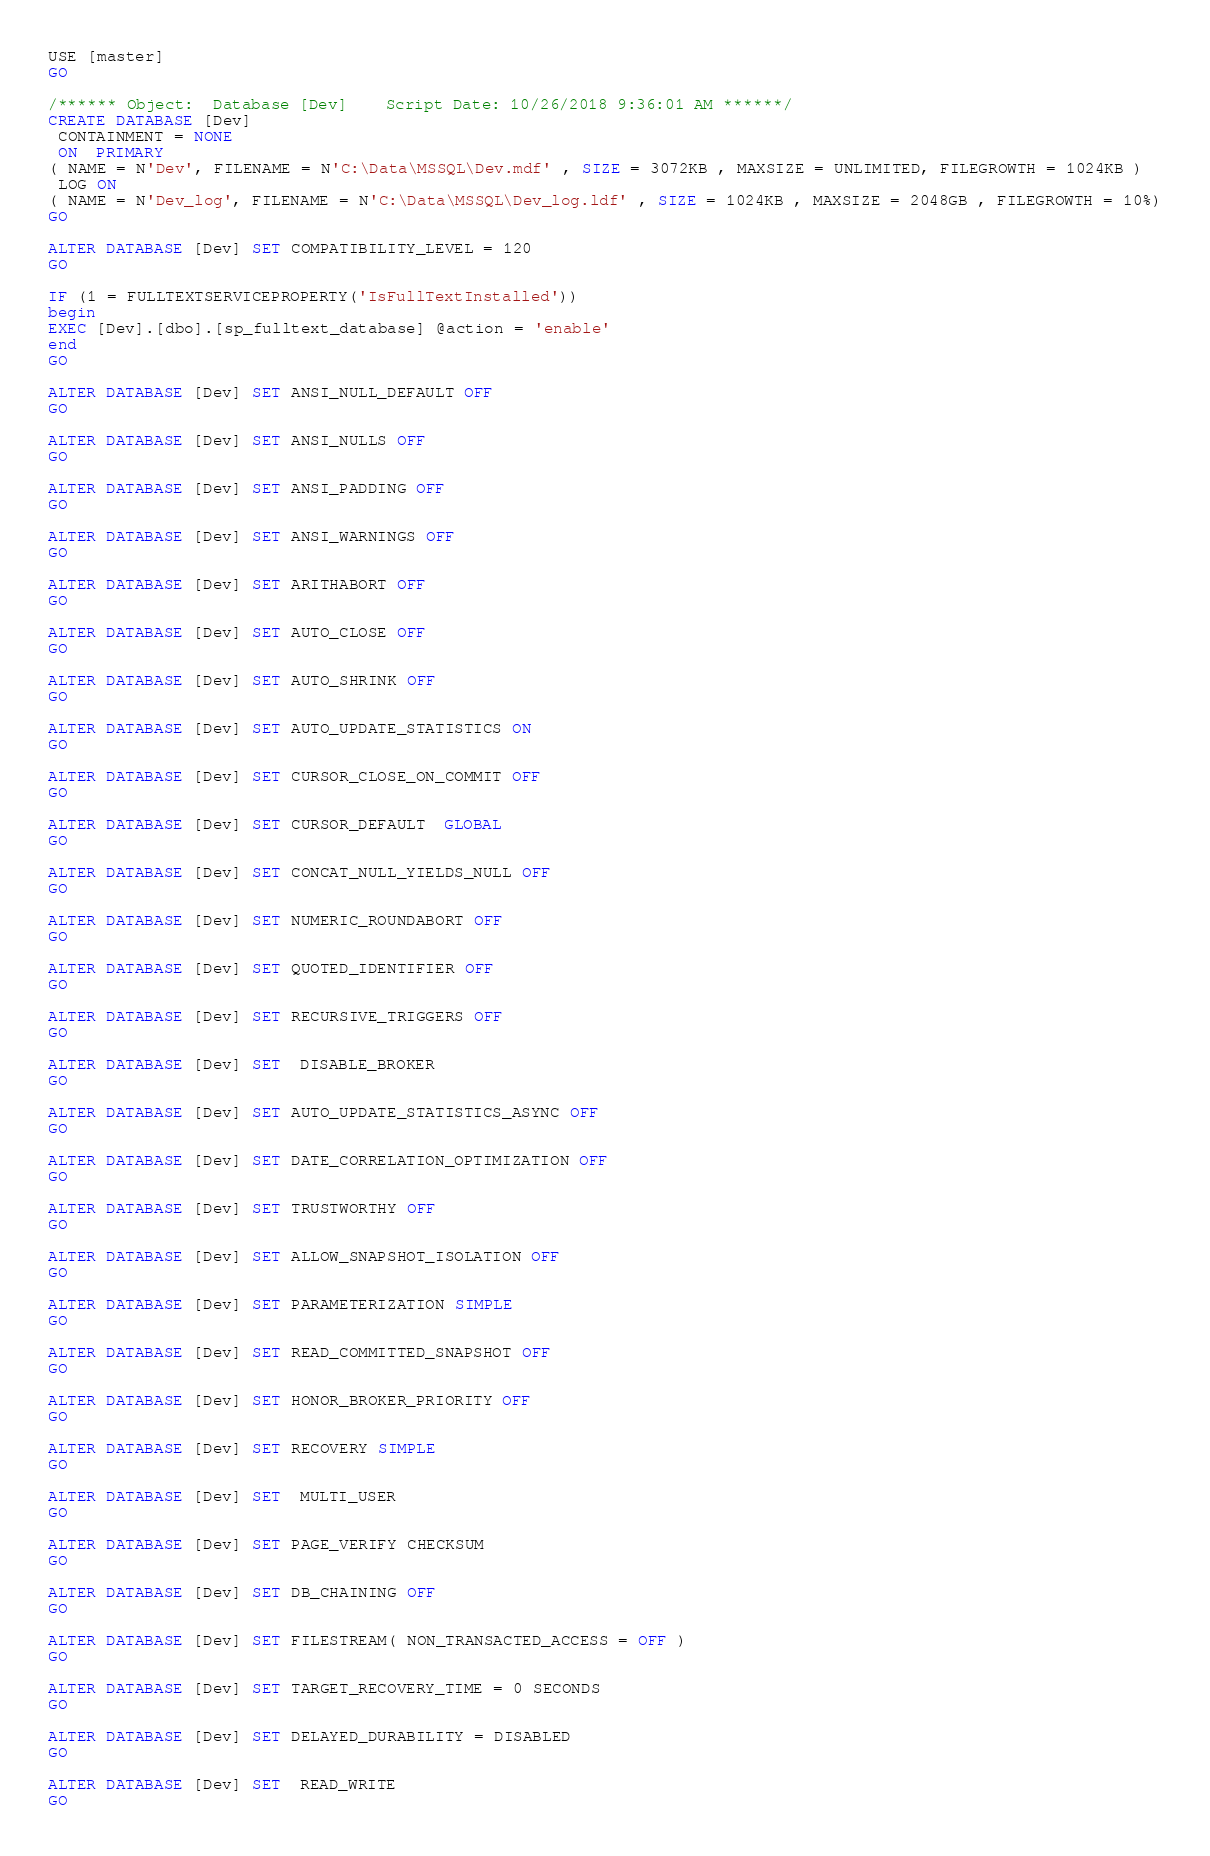Convert code to text. <code><loc_0><loc_0><loc_500><loc_500><_SQL_>USE [master]
GO

/****** Object:  Database [Dev]    Script Date: 10/26/2018 9:36:01 AM ******/
CREATE DATABASE [Dev]
 CONTAINMENT = NONE
 ON  PRIMARY 
( NAME = N'Dev', FILENAME = N'C:\Data\MSSQL\Dev.mdf' , SIZE = 3072KB , MAXSIZE = UNLIMITED, FILEGROWTH = 1024KB )
 LOG ON 
( NAME = N'Dev_log', FILENAME = N'C:\Data\MSSQL\Dev_log.ldf' , SIZE = 1024KB , MAXSIZE = 2048GB , FILEGROWTH = 10%)
GO

ALTER DATABASE [Dev] SET COMPATIBILITY_LEVEL = 120
GO

IF (1 = FULLTEXTSERVICEPROPERTY('IsFullTextInstalled'))
begin
EXEC [Dev].[dbo].[sp_fulltext_database] @action = 'enable'
end
GO

ALTER DATABASE [Dev] SET ANSI_NULL_DEFAULT OFF 
GO

ALTER DATABASE [Dev] SET ANSI_NULLS OFF 
GO

ALTER DATABASE [Dev] SET ANSI_PADDING OFF 
GO

ALTER DATABASE [Dev] SET ANSI_WARNINGS OFF 
GO

ALTER DATABASE [Dev] SET ARITHABORT OFF 
GO

ALTER DATABASE [Dev] SET AUTO_CLOSE OFF 
GO

ALTER DATABASE [Dev] SET AUTO_SHRINK OFF 
GO

ALTER DATABASE [Dev] SET AUTO_UPDATE_STATISTICS ON 
GO

ALTER DATABASE [Dev] SET CURSOR_CLOSE_ON_COMMIT OFF 
GO

ALTER DATABASE [Dev] SET CURSOR_DEFAULT  GLOBAL 
GO

ALTER DATABASE [Dev] SET CONCAT_NULL_YIELDS_NULL OFF 
GO

ALTER DATABASE [Dev] SET NUMERIC_ROUNDABORT OFF 
GO

ALTER DATABASE [Dev] SET QUOTED_IDENTIFIER OFF 
GO

ALTER DATABASE [Dev] SET RECURSIVE_TRIGGERS OFF 
GO

ALTER DATABASE [Dev] SET  DISABLE_BROKER 
GO

ALTER DATABASE [Dev] SET AUTO_UPDATE_STATISTICS_ASYNC OFF 
GO

ALTER DATABASE [Dev] SET DATE_CORRELATION_OPTIMIZATION OFF 
GO

ALTER DATABASE [Dev] SET TRUSTWORTHY OFF 
GO

ALTER DATABASE [Dev] SET ALLOW_SNAPSHOT_ISOLATION OFF 
GO

ALTER DATABASE [Dev] SET PARAMETERIZATION SIMPLE 
GO

ALTER DATABASE [Dev] SET READ_COMMITTED_SNAPSHOT OFF 
GO

ALTER DATABASE [Dev] SET HONOR_BROKER_PRIORITY OFF 
GO

ALTER DATABASE [Dev] SET RECOVERY SIMPLE 
GO

ALTER DATABASE [Dev] SET  MULTI_USER 
GO

ALTER DATABASE [Dev] SET PAGE_VERIFY CHECKSUM  
GO

ALTER DATABASE [Dev] SET DB_CHAINING OFF 
GO

ALTER DATABASE [Dev] SET FILESTREAM( NON_TRANSACTED_ACCESS = OFF ) 
GO

ALTER DATABASE [Dev] SET TARGET_RECOVERY_TIME = 0 SECONDS 
GO

ALTER DATABASE [Dev] SET DELAYED_DURABILITY = DISABLED 
GO

ALTER DATABASE [Dev] SET  READ_WRITE 
GO


</code> 